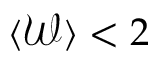<formula> <loc_0><loc_0><loc_500><loc_500>\langle \mathcal { W } \rangle < 2</formula> 